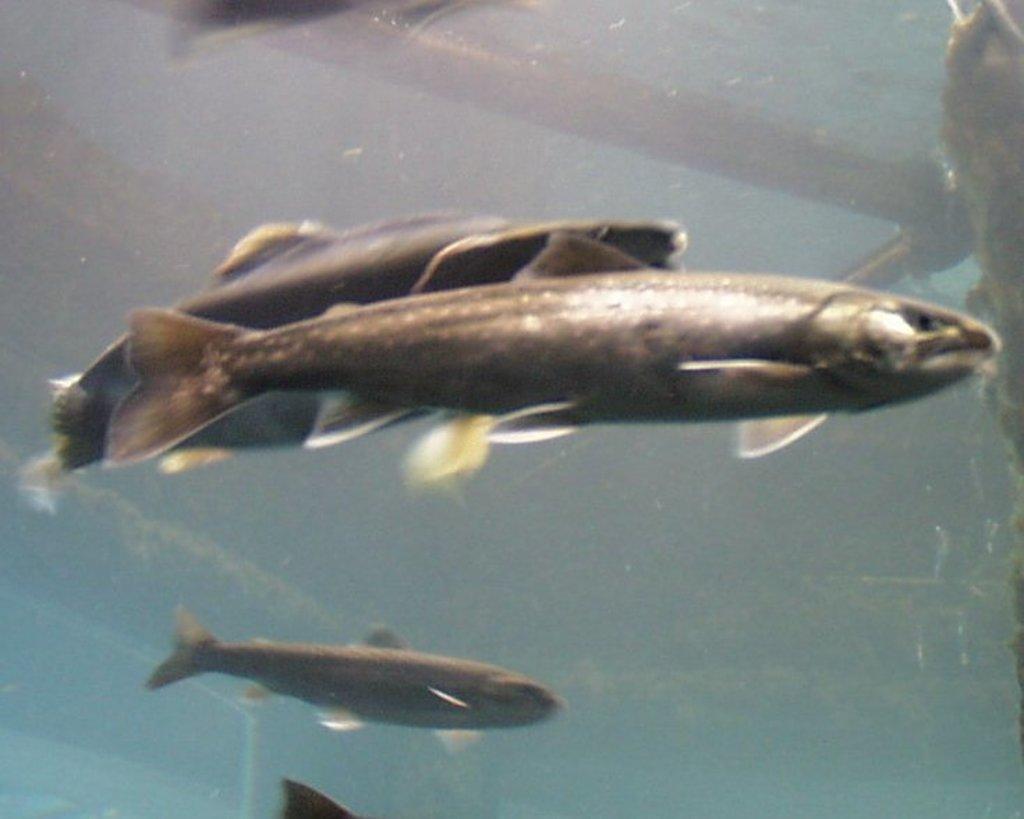How would you summarize this image in a sentence or two? In this image I can see few fishes in the water. 